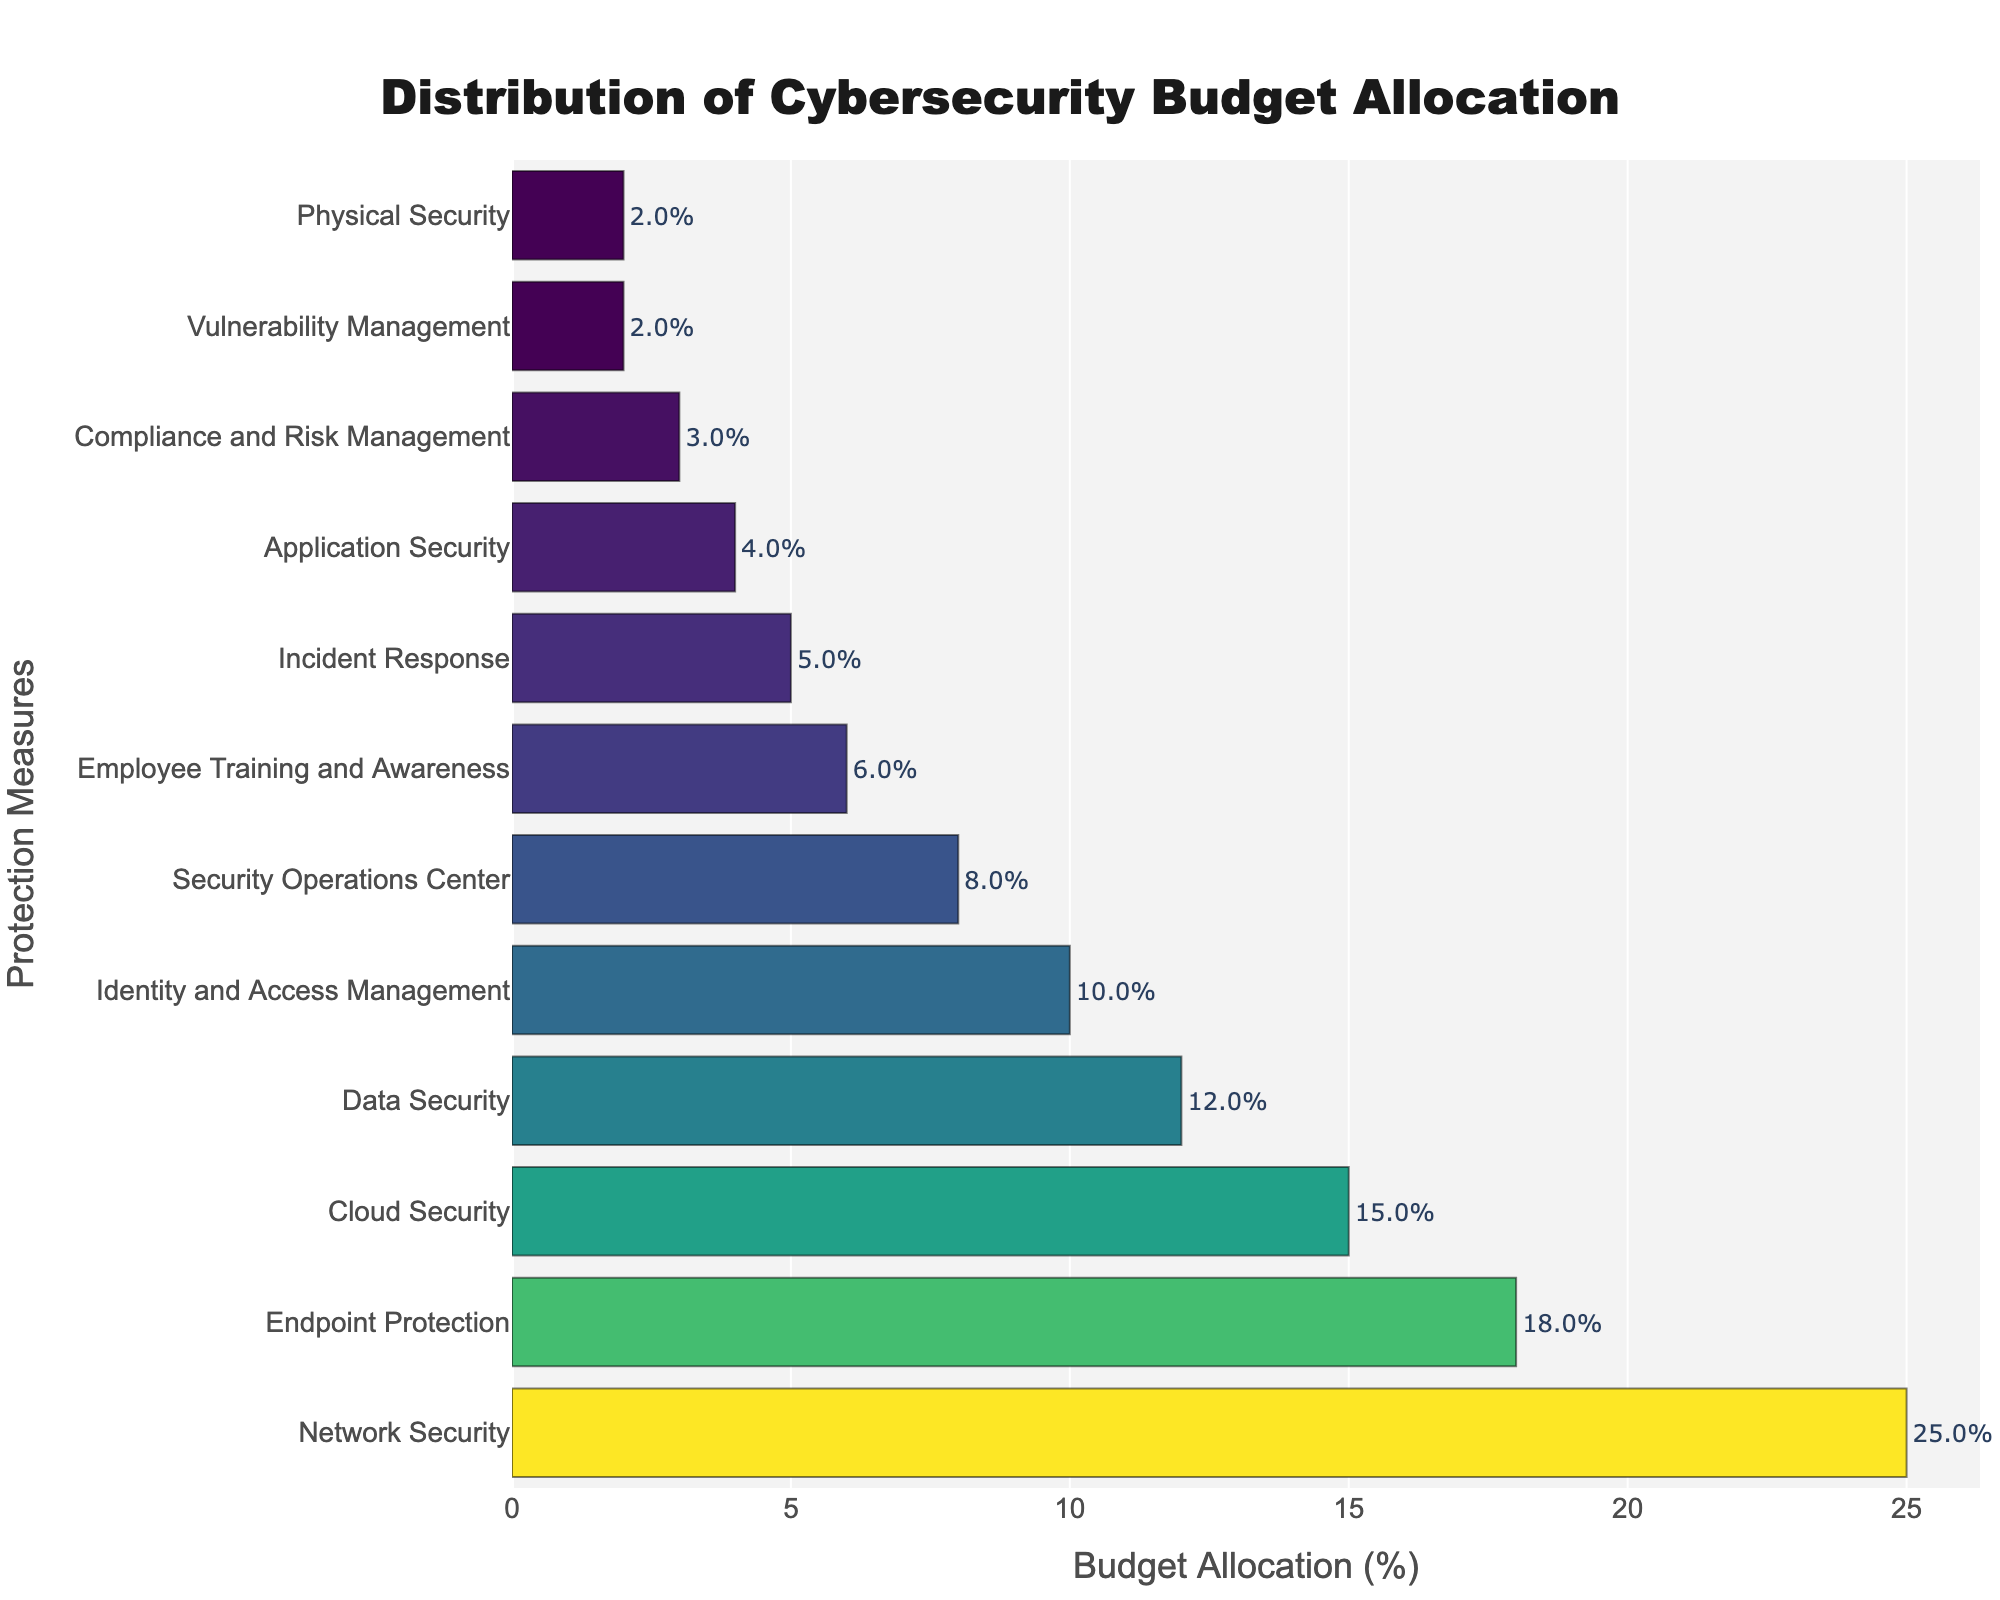Which protection measure has the highest budget allocation? The bar for "Network Security" is the longest, indicating it has the highest budget allocation percentage.
Answer: Network Security Which two measures have the lowest budget allocation, and what are their percentages? The two shortest bars belong to "Vulnerability Management" and "Physical Security," both with a budget allocation percentage of 2%.
Answer: Vulnerability Management and Physical Security, 2% each By how much does the budget allocation for Network Security exceed that for Endpoint Protection? Network Security has a budget allocation of 25%, and Endpoint Protection has 18%. The difference is 25% - 18% = 7%.
Answer: 7% What is the total budget allocation for Cloud Security, Data Security, and Identity and Access Management combined? The budget allocations for Cloud Security, Data Security, and Identity and Access Management are 15%, 12%, and 10% respectively. The total is 15% + 12% + 10% = 37%.
Answer: 37% Which measure has a budget allocation closest to the average allocation percentage of all categories, and what is that average? The total budget allocation is 100%. There are 12 categories, so the average allocation is 100% / 12 ≈ 8.33%. The closest measure to this average is "Security Operations Center" with 8%.
Answer: Security Operations Center, 8% How does the budget for Application Security compare to that for Employee Training and Awareness? Application Security has a budget allocation of 4%, while Employee Training and Awareness has 6%. Therefore, Employee Training and Awareness has a higher allocation.
Answer: Employee Training and Awareness What percentage of the budget is allocated to measures tied to direct threat response, namely Security Operations Center and Incident Response? The budget allocations for Security Operations Center and Incident Response are 8% and 5% respectively. The total is 8% + 5% = 13%.
Answer: 13% Which category has the third highest budget allocation, and what is its percentage? The third longest bar is for "Cloud Security," with a budget allocation percentage of 15%.
Answer: Cloud Security, 15% What is the combined budget allocation for Endpoint Protection and Data Security, and how does it compare to Network Security? Endpoint Protection and Data Security have allocations of 18% and 12% respectively, totaling 30%. Comparing this to Network Security’s 25%, 30% is greater.
Answer: 30%, greater Which two categories have a combined budget allocation equal to that of Network Security, if any? Network Security has an allocation of 25%. Combining "Data Security" (12%) and "Endpoint Protection" (18%) equals 30%, which is greater than 25%. Combining "Security Operations Center" (8%) and "Cloud Security" (15%) equals 23%, which is less. Thus, none of the pairs equal 25%.
Answer: None 